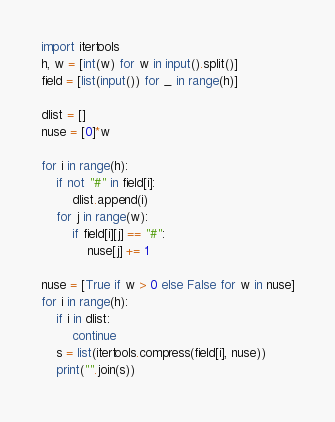Convert code to text. <code><loc_0><loc_0><loc_500><loc_500><_Python_>import itertools
h, w = [int(w) for w in input().split()]
field = [list(input()) for _ in range(h)]

dlist = []
nuse = [0]*w

for i in range(h):
    if not "#" in field[i]:
        dlist.append(i)
    for j in range(w):
        if field[i][j] == "#":
            nuse[j] += 1

nuse = [True if w > 0 else False for w in nuse]
for i in range(h):
    if i in dlist:
        continue
    s = list(itertools.compress(field[i], nuse))
    print("".join(s))
</code> 